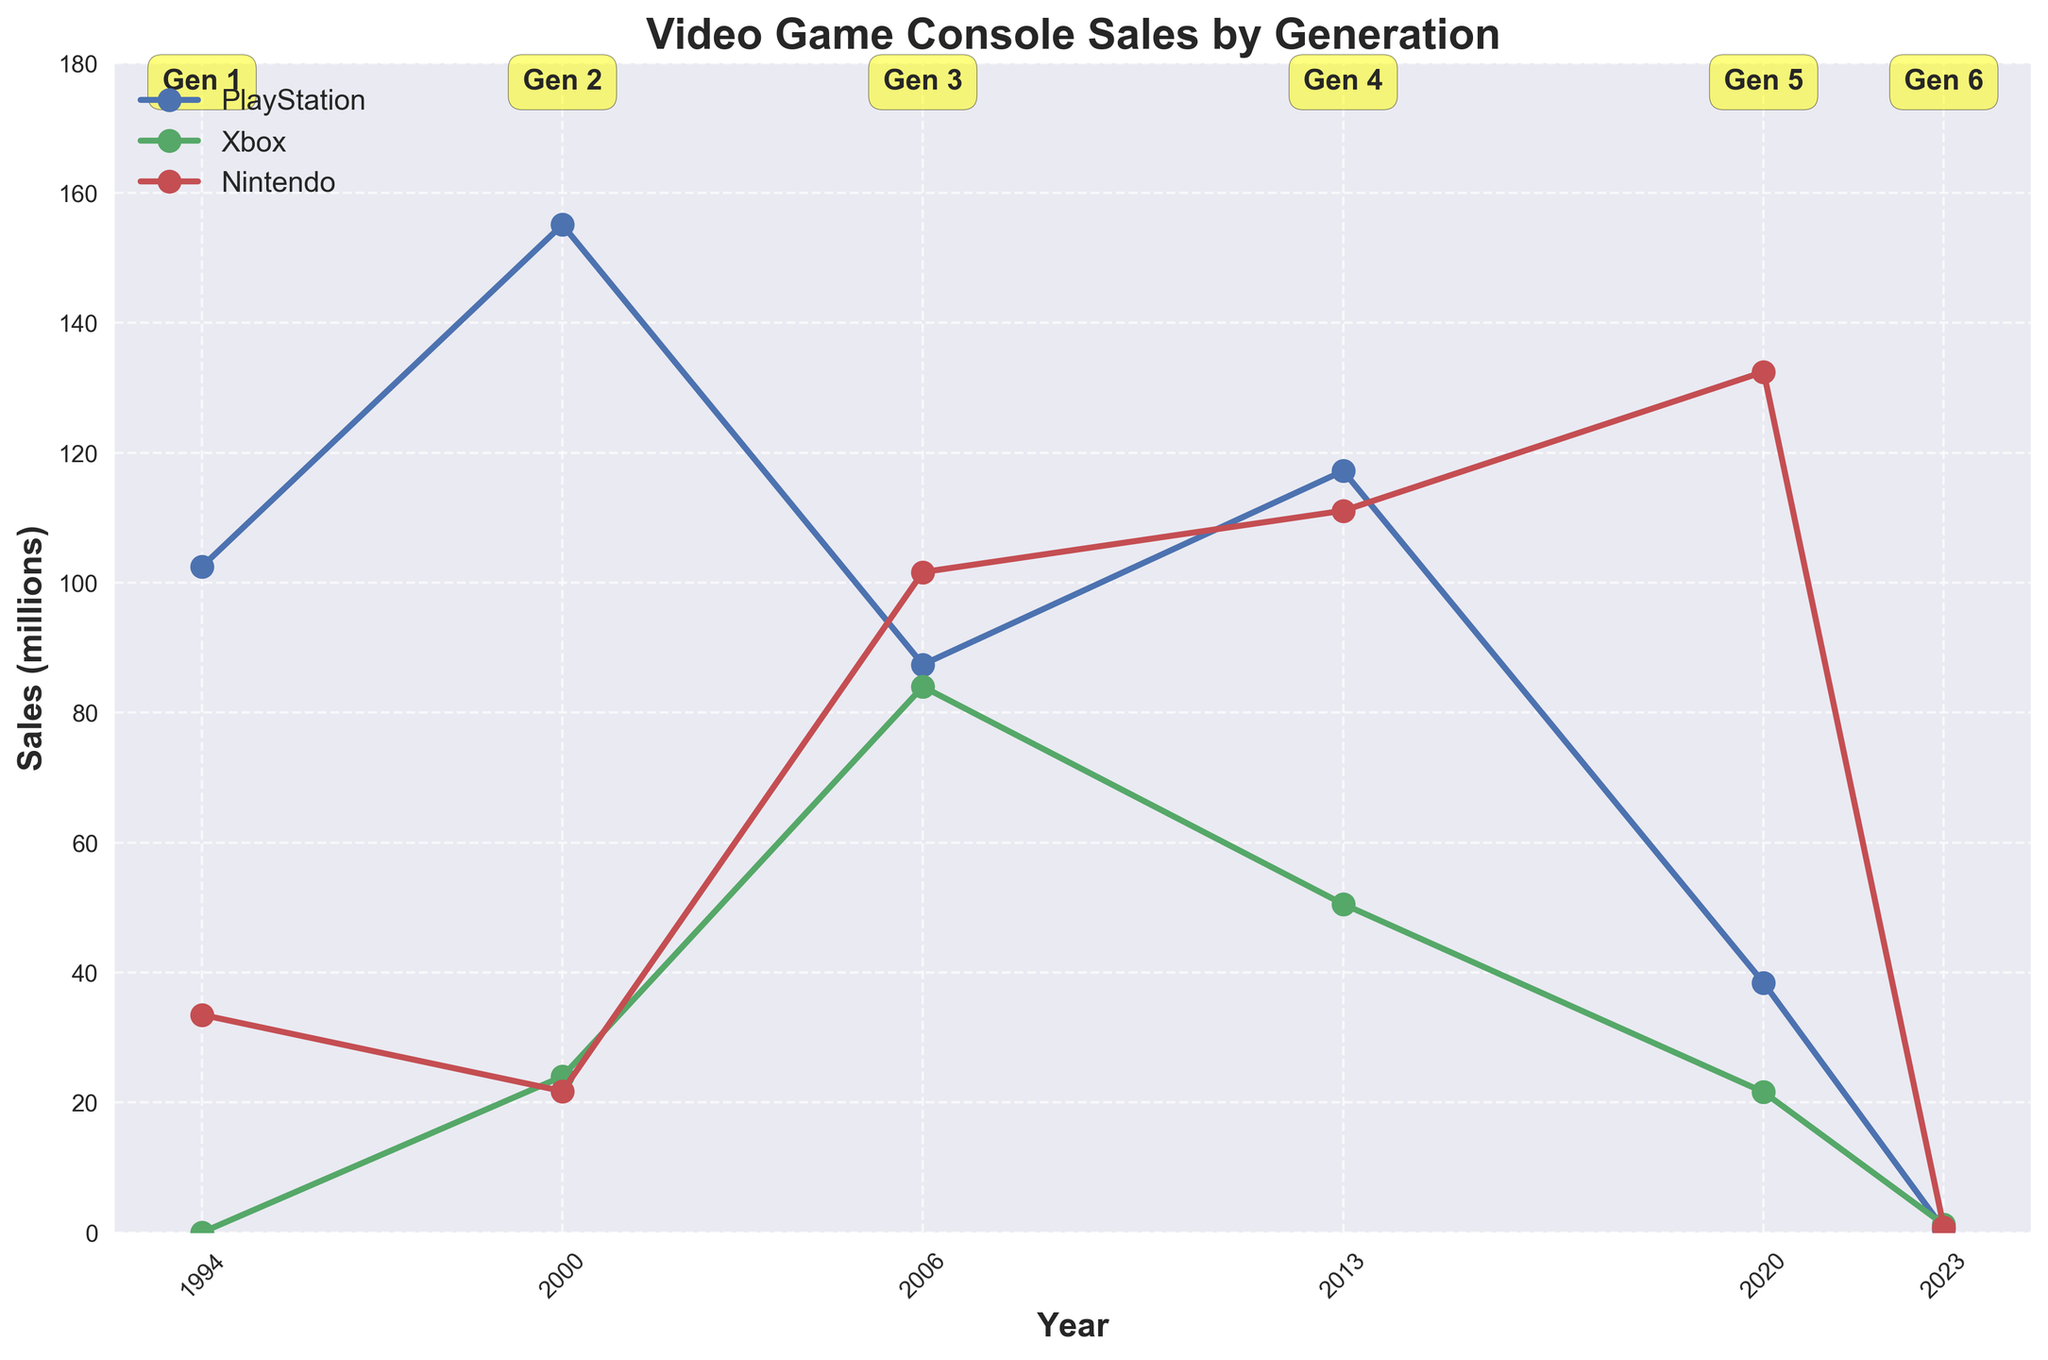Which console had the highest sales in Generation 1? The figure shows the sales for PlayStation, Xbox, and Nintendo in Generation 1. Looking at the data for 1994, PlayStation had 102.49 million sales, Xbox had 0, and Nintendo had 33.49 million. Therefore, PlayStation had the highest sales.
Answer: PlayStation How did the sales of Xbox in Generation 5 compare to its sales in Generation 4? Comparing the sales figures for Xbox in Generation 4 (2013) and Generation 5 (2020) on the graph, Xbox had 50.53 million sales in 2013 and 21.59 million sales in 2020. Subtracting the Generation 5 sales from Generation 4, 50.53 - 21.59 = 28.94 million. Xbox sales decreased by 28.94 million.
Answer: Decreased by 28.94 million What is the sum of Nintendo sales across all generations? Summing up the Nintendo sales across all generations visible on the graph: 33.49 (1994) + 21.74 (2000) + 101.63 (2006) + 111.08 (2013) + 132.46 (2020) + 0.8 (2023) = 401.2 million.
Answer: 401.2 million Which year saw the highest sales for Nintendo? The highest point for Nintendo on the chart appears in 2020. According to the data, Nintendo sales were 132.46 million in that year. Therefore, 2020 was the peak year for Nintendo.
Answer: 2020 What is the average sales for PlayStation across all generations? To find the average sales for PlayStation, sum the sales across all generations and then divide by the number of generations. Sum: 102.49 + 155.1 + 87.4 + 117.2 + 38.4 + 0.5 = 501.09 million. Number of generations: 6. Average: 501.09 / 6 = 83.515 million.
Answer: 83.515 million By how much did PlayStation sales decrease from Generation 2 to Generation 3? The sales for PlayStation in Generation 2 (2000) were 155.1 million and in Generation 3 (2006) were 87.4 million. Decrease: 155.1 - 87.4 = 67.7 million.
Answer: 67.7 million Among the three consoles, which had the most consistent sales performance across the generations? Consistency can be interpreted as the smallest variance in sales numbers across generations. By looking at the sales figures on the graph for PlayStation, Xbox, and Nintendo, PlayStation and Xbox both show significant variances with peaks and troughs. Nintendo, while having higher peaks, seems relatively more consistent. Still, reviewing sales for a precise quantitative measure would be ideal, yet visually Nintendo appears more consistent.
Answer: Nintendo 